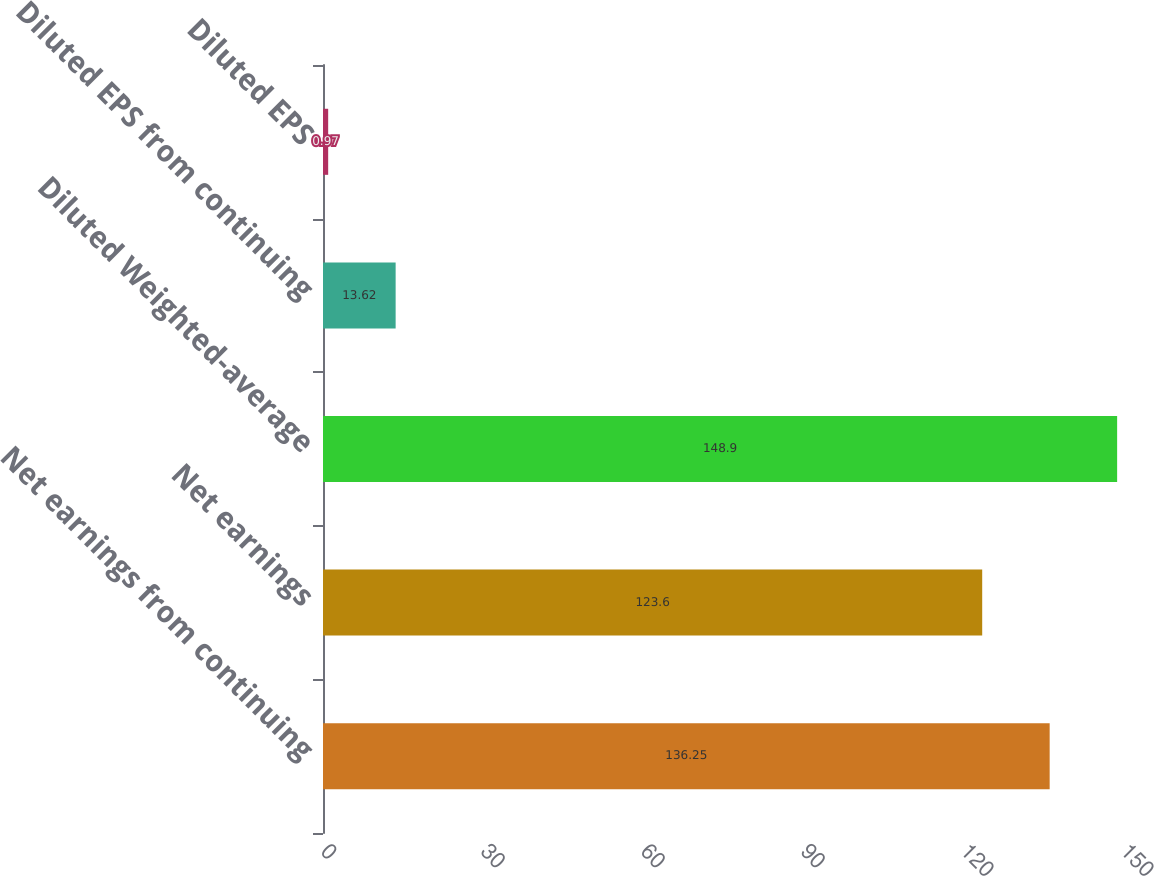<chart> <loc_0><loc_0><loc_500><loc_500><bar_chart><fcel>Net earnings from continuing<fcel>Net earnings<fcel>Diluted Weighted-average<fcel>Diluted EPS from continuing<fcel>Diluted EPS<nl><fcel>136.25<fcel>123.6<fcel>148.9<fcel>13.62<fcel>0.97<nl></chart> 